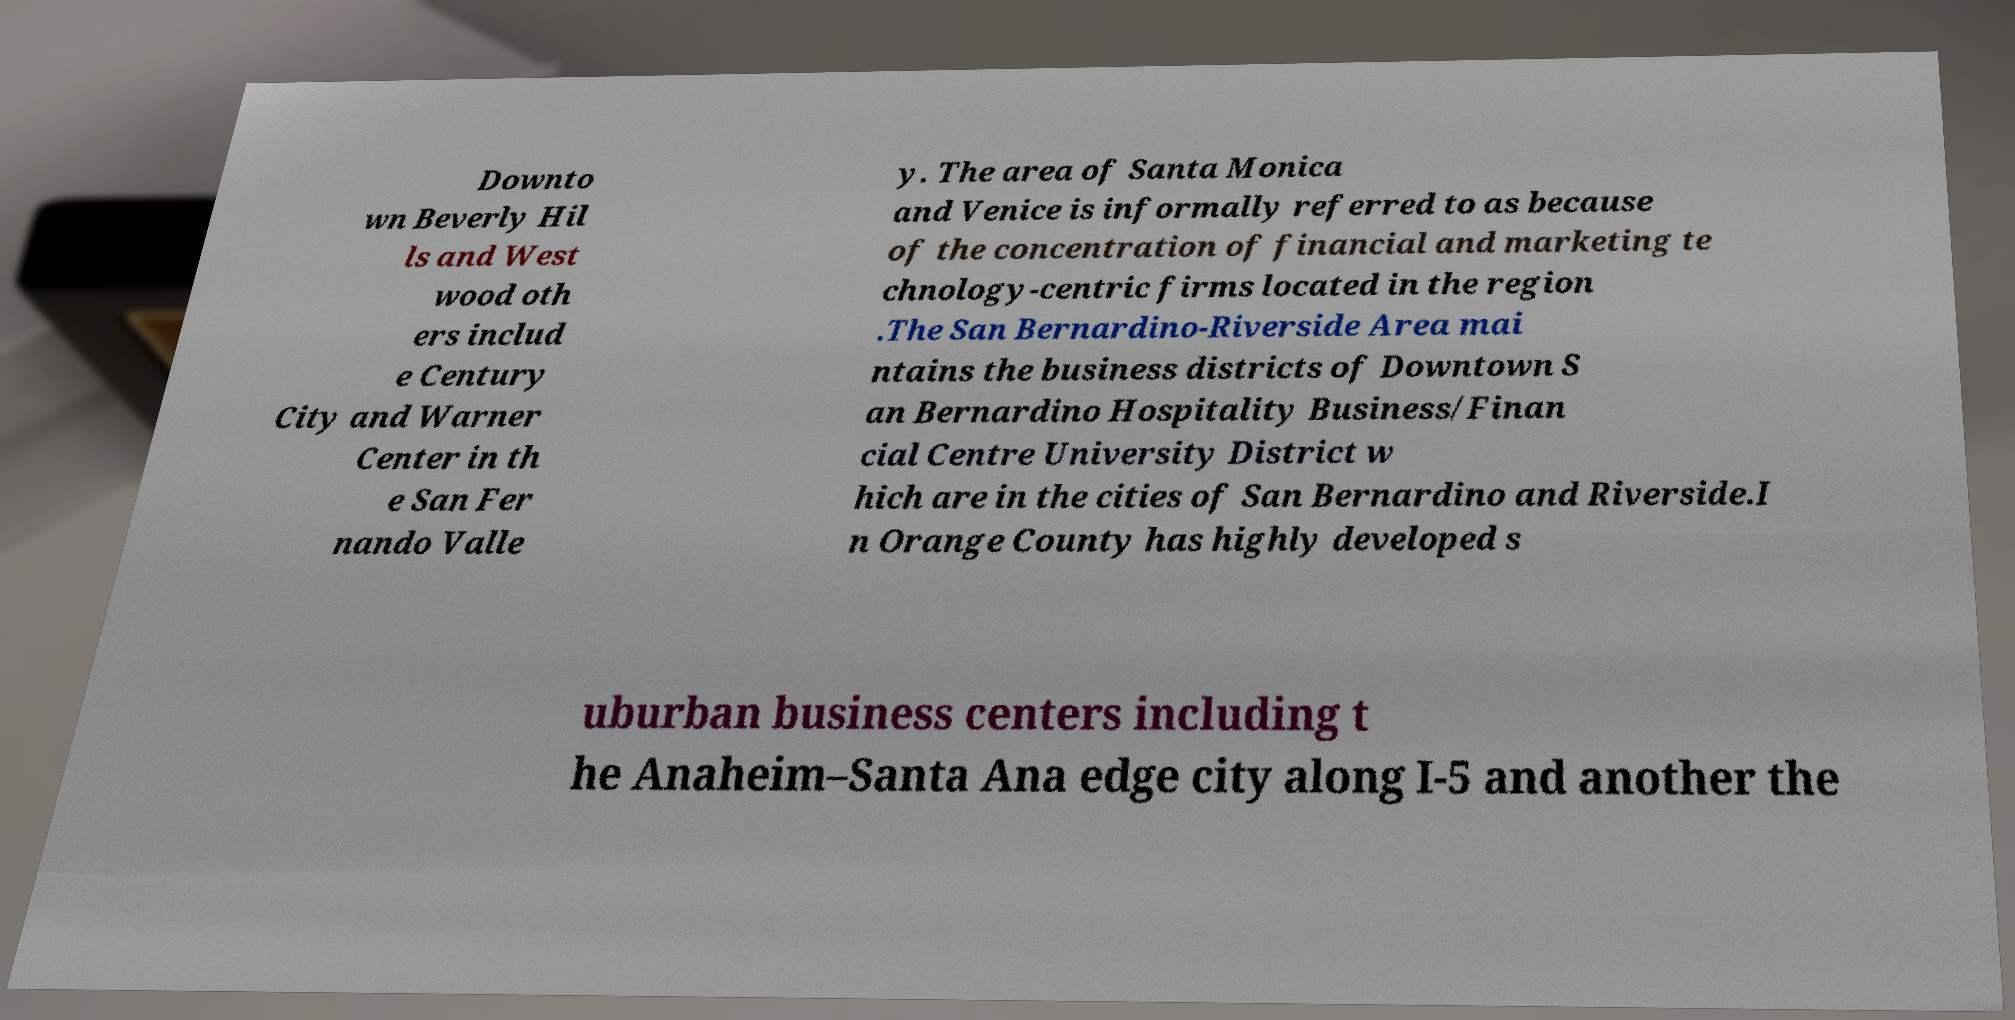Please read and relay the text visible in this image. What does it say? Downto wn Beverly Hil ls and West wood oth ers includ e Century City and Warner Center in th e San Fer nando Valle y. The area of Santa Monica and Venice is informally referred to as because of the concentration of financial and marketing te chnology-centric firms located in the region .The San Bernardino-Riverside Area mai ntains the business districts of Downtown S an Bernardino Hospitality Business/Finan cial Centre University District w hich are in the cities of San Bernardino and Riverside.I n Orange County has highly developed s uburban business centers including t he Anaheim–Santa Ana edge city along I-5 and another the 